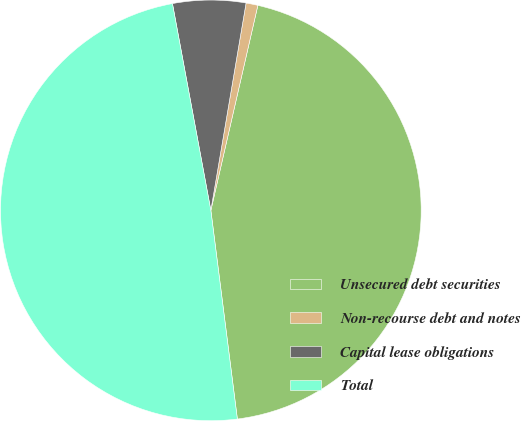Convert chart. <chart><loc_0><loc_0><loc_500><loc_500><pie_chart><fcel>Unsecured debt securities<fcel>Non-recourse debt and notes<fcel>Capital lease obligations<fcel>Total<nl><fcel>44.4%<fcel>0.91%<fcel>5.6%<fcel>49.09%<nl></chart> 